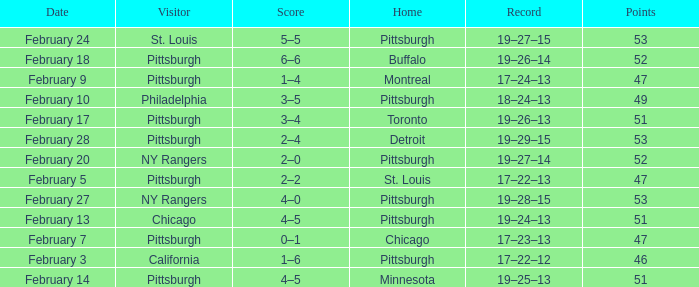Which Score has a Date of february 9? 1–4. 